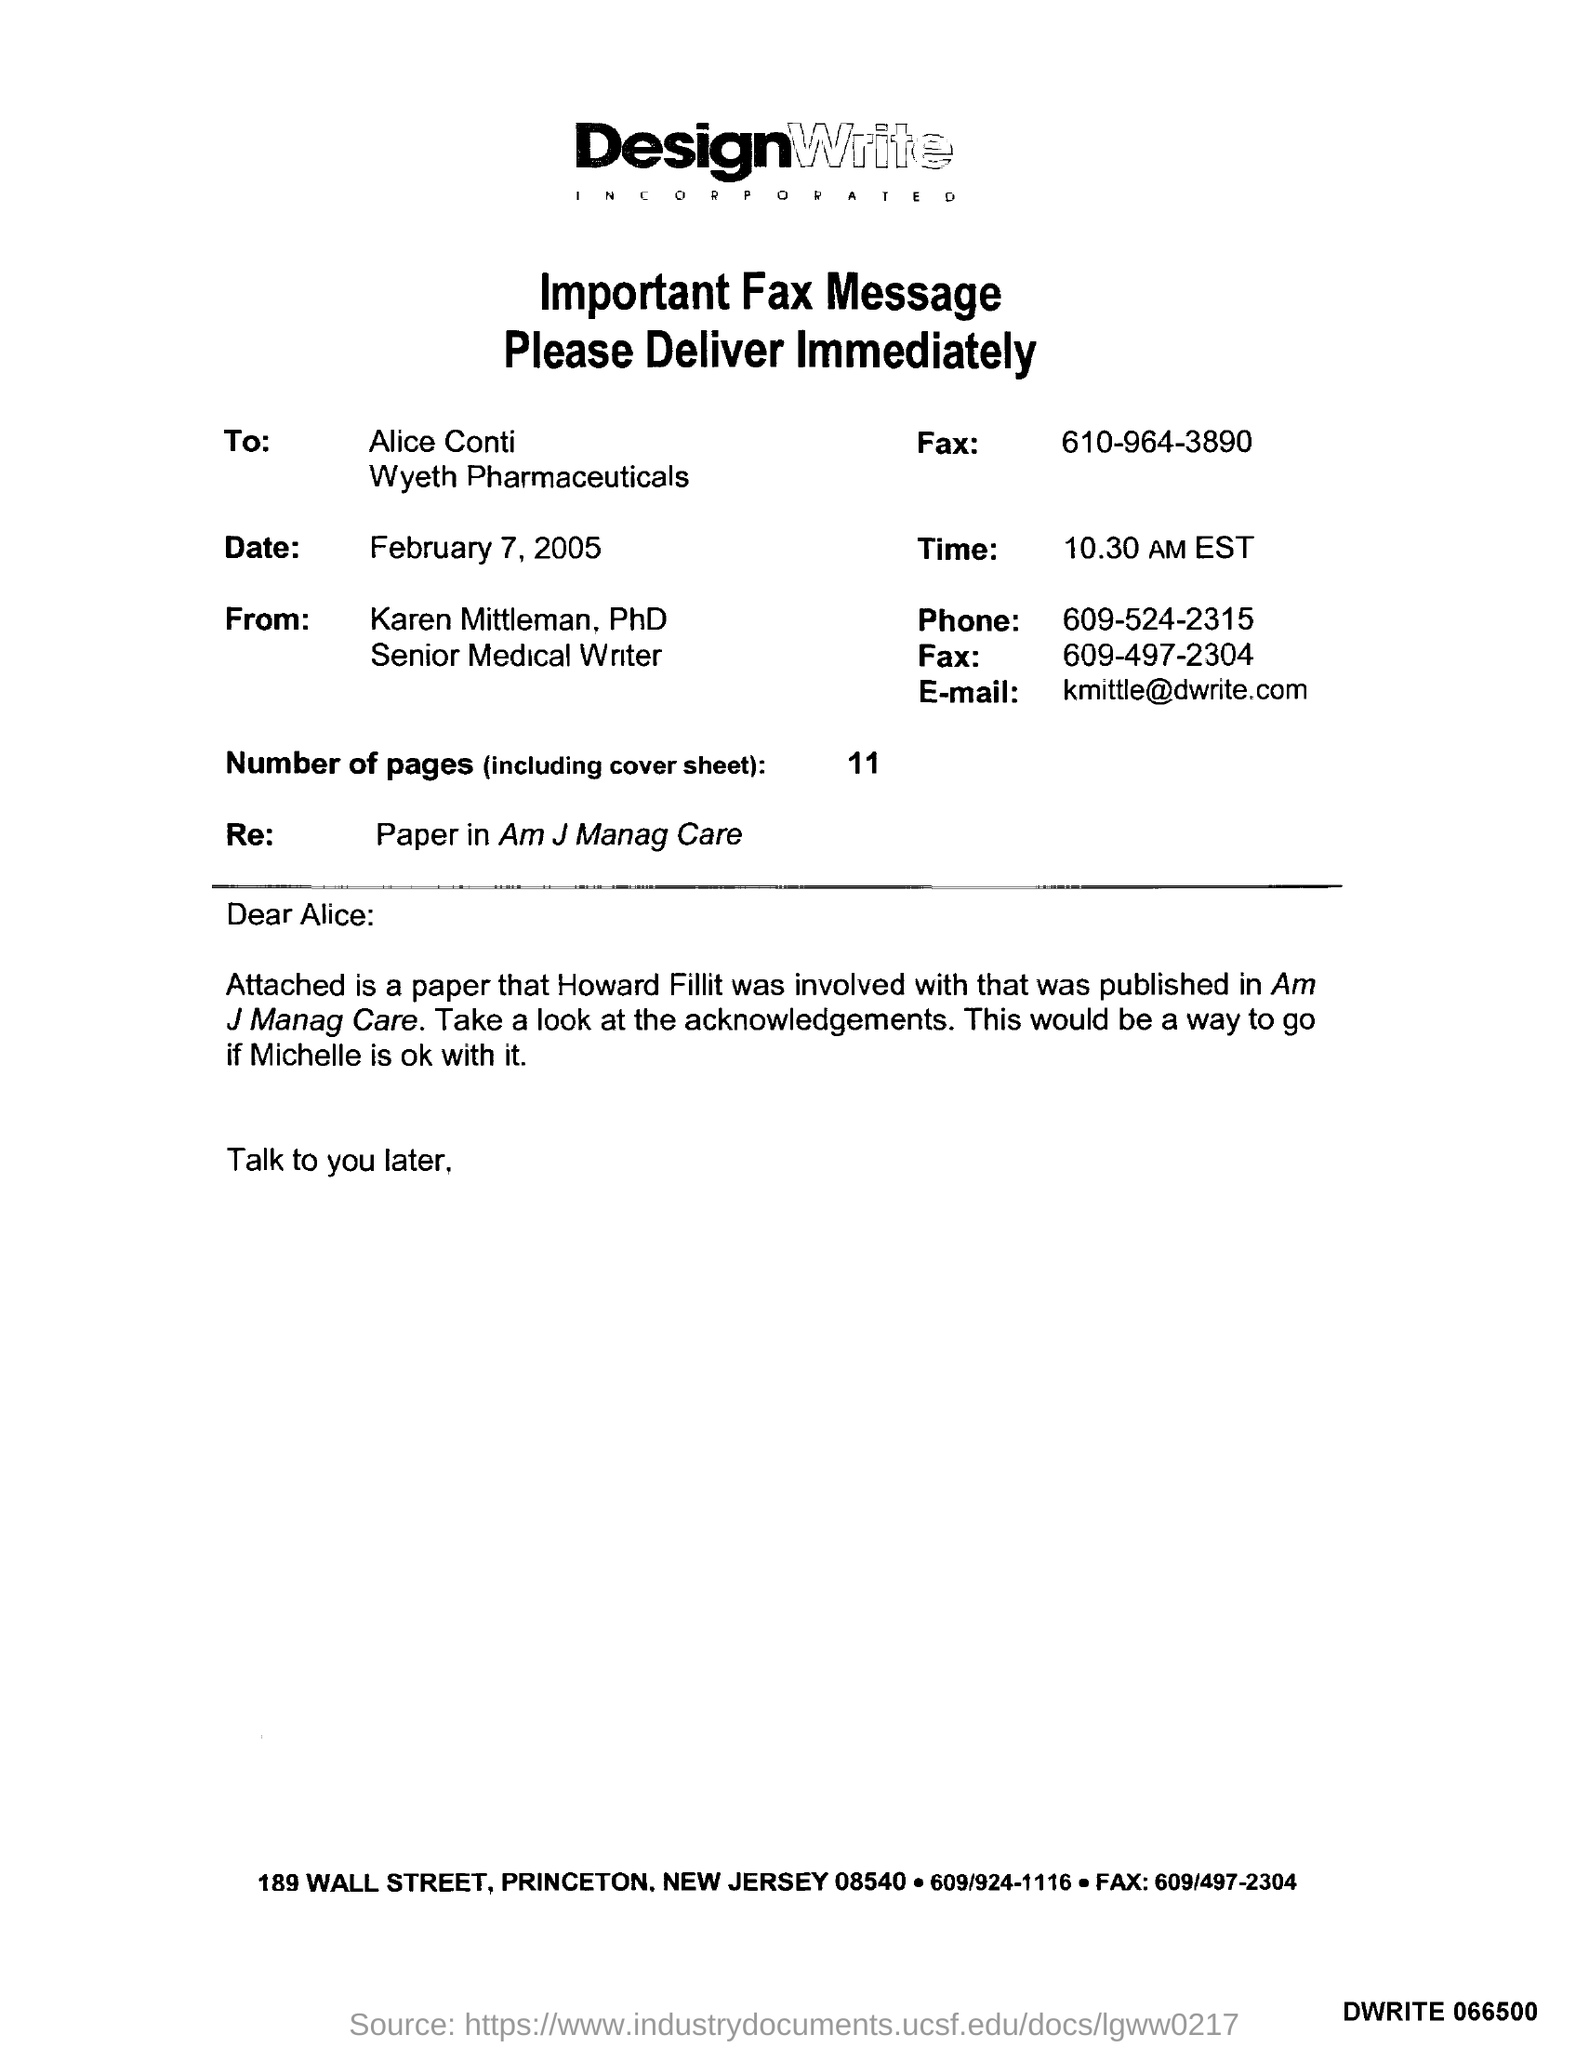To Whom is this Fax addressed to?
Your answer should be very brief. Alice Conti. What is the Date?
Offer a terse response. February 7, 2005. What is the Time?
Your answer should be compact. 10.30 AM EST. Who is this Fax from?
Ensure brevity in your answer.  Karen Mittleman, PhD. What is the Phone?
Offer a terse response. 609-524-2315. What is the E-mail?
Offer a very short reply. Kmittle@dwrite.com. What is the Re: ?
Your answer should be very brief. Paper in Am J Manag Care. What are the Number of Pages (including cover sheet)?
Provide a short and direct response. 11. 